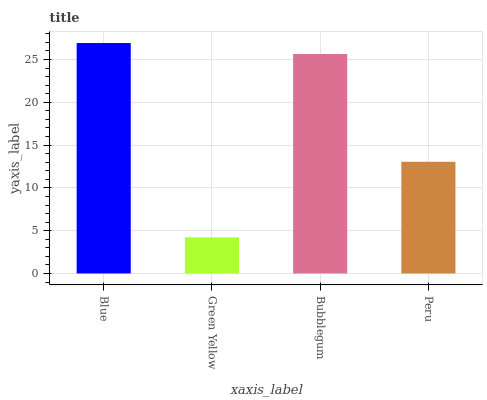Is Green Yellow the minimum?
Answer yes or no. Yes. Is Blue the maximum?
Answer yes or no. Yes. Is Bubblegum the minimum?
Answer yes or no. No. Is Bubblegum the maximum?
Answer yes or no. No. Is Bubblegum greater than Green Yellow?
Answer yes or no. Yes. Is Green Yellow less than Bubblegum?
Answer yes or no. Yes. Is Green Yellow greater than Bubblegum?
Answer yes or no. No. Is Bubblegum less than Green Yellow?
Answer yes or no. No. Is Bubblegum the high median?
Answer yes or no. Yes. Is Peru the low median?
Answer yes or no. Yes. Is Green Yellow the high median?
Answer yes or no. No. Is Blue the low median?
Answer yes or no. No. 